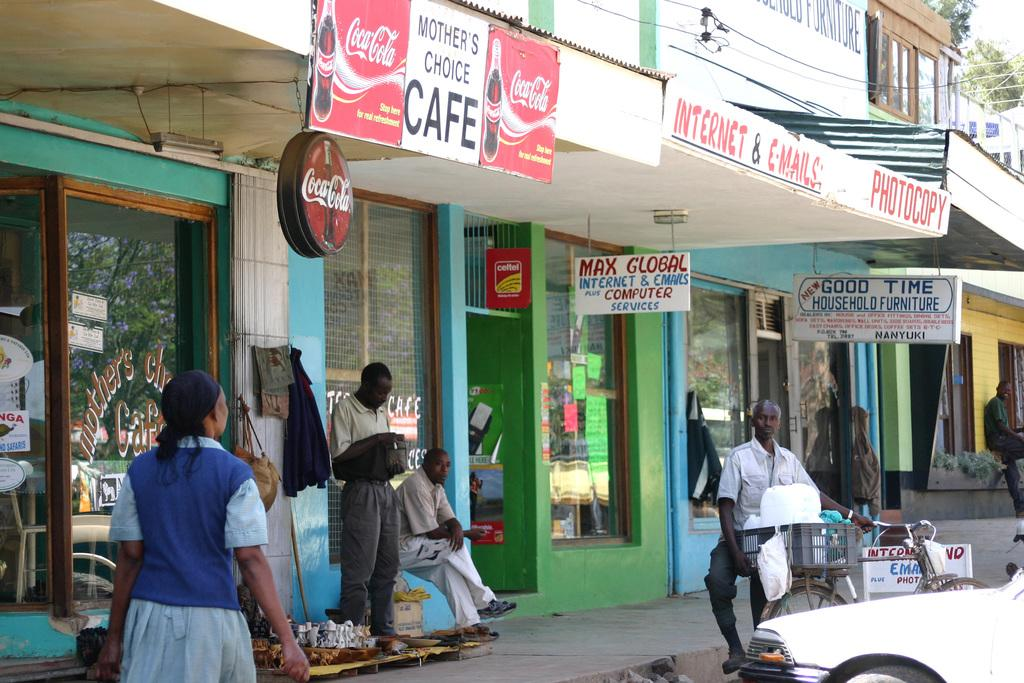<image>
Share a concise interpretation of the image provided. People sitting and standing in front of a shop that says "Internet & Emails". 